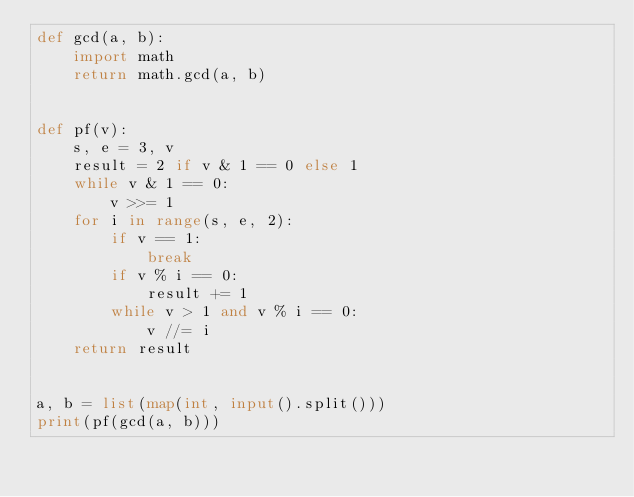<code> <loc_0><loc_0><loc_500><loc_500><_Python_>def gcd(a, b):
    import math
    return math.gcd(a, b)


def pf(v):
    s, e = 3, v
    result = 2 if v & 1 == 0 else 1
    while v & 1 == 0:
        v >>= 1
    for i in range(s, e, 2):
        if v == 1:
            break
        if v % i == 0:
            result += 1
        while v > 1 and v % i == 0:
            v //= i
    return result


a, b = list(map(int, input().split()))
print(pf(gcd(a, b)))
</code> 